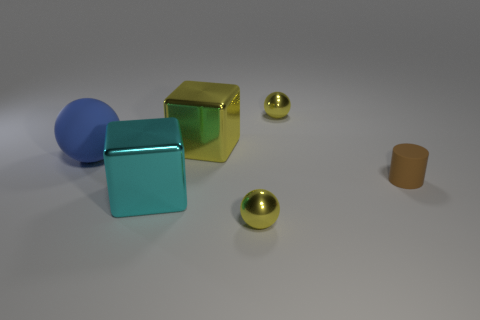Add 1 tiny green blocks. How many objects exist? 7 Subtract all rubber spheres. How many spheres are left? 2 Subtract 1 spheres. How many spheres are left? 2 Subtract all cylinders. How many objects are left? 5 Subtract all brown balls. Subtract all yellow cubes. How many balls are left? 3 Add 1 blue shiny objects. How many blue shiny objects exist? 1 Subtract 0 blue cubes. How many objects are left? 6 Subtract all brown cylinders. Subtract all big yellow metal cubes. How many objects are left? 4 Add 5 tiny brown things. How many tiny brown things are left? 6 